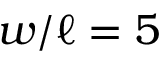Convert formula to latex. <formula><loc_0><loc_0><loc_500><loc_500>w / \ell = 5</formula> 